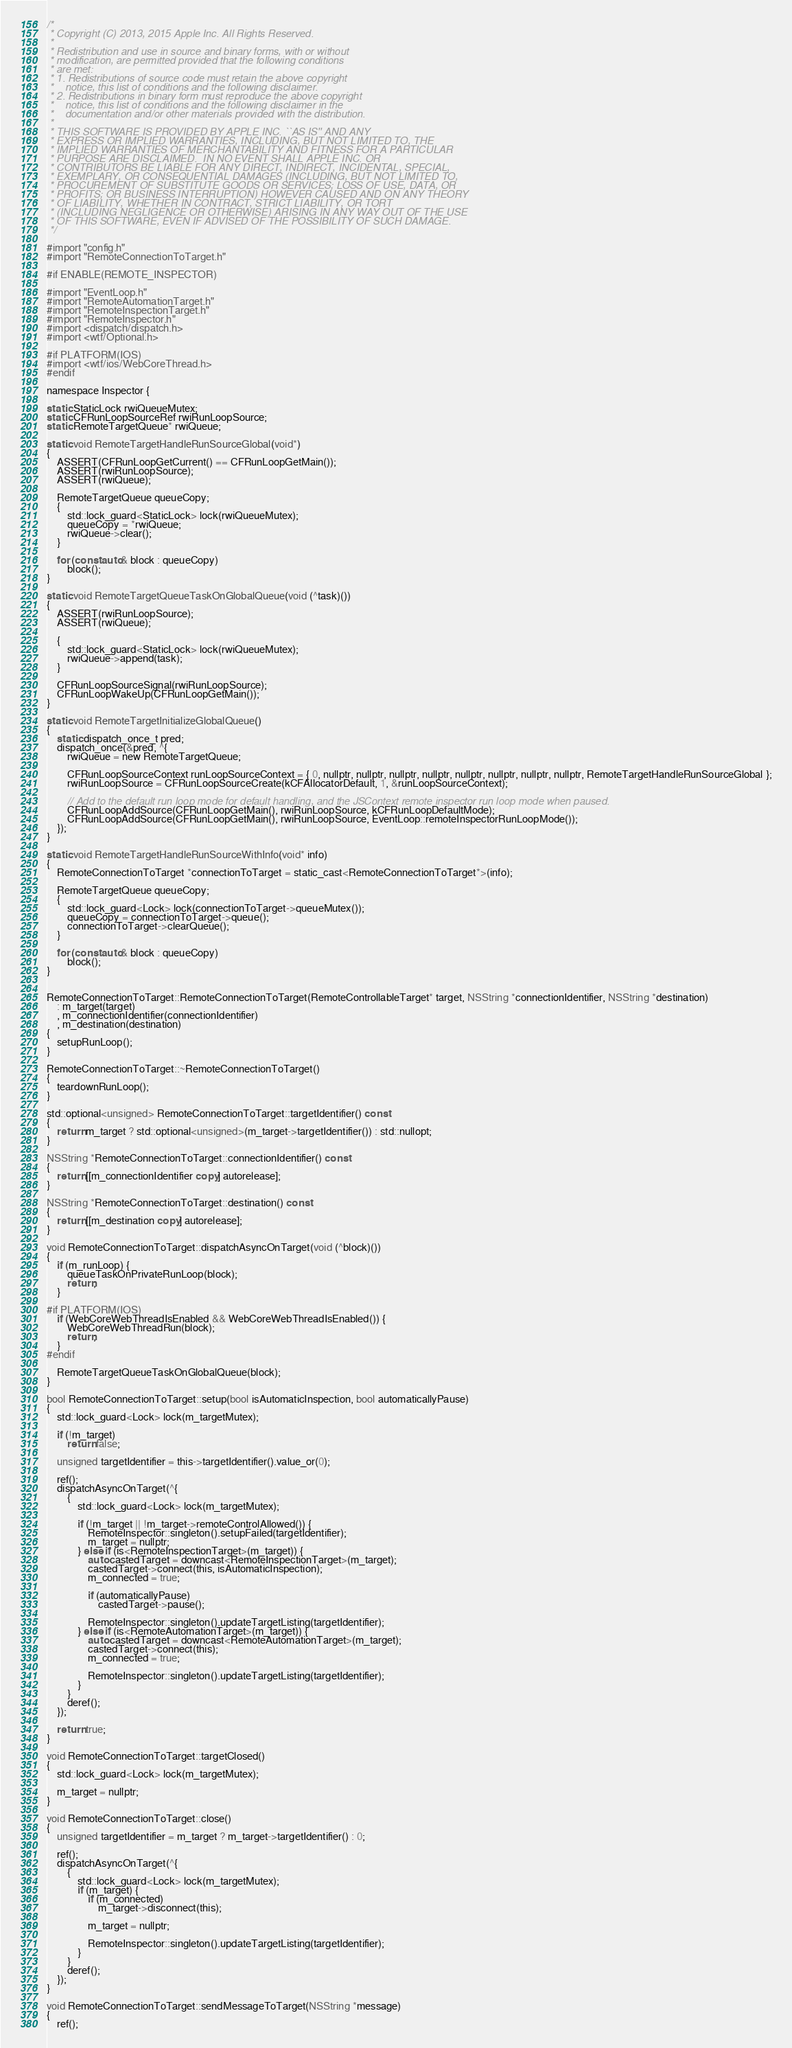<code> <loc_0><loc_0><loc_500><loc_500><_ObjectiveC_>/*
 * Copyright (C) 2013, 2015 Apple Inc. All Rights Reserved.
 *
 * Redistribution and use in source and binary forms, with or without
 * modification, are permitted provided that the following conditions
 * are met:
 * 1. Redistributions of source code must retain the above copyright
 *    notice, this list of conditions and the following disclaimer.
 * 2. Redistributions in binary form must reproduce the above copyright
 *    notice, this list of conditions and the following disclaimer in the
 *    documentation and/or other materials provided with the distribution.
 *
 * THIS SOFTWARE IS PROVIDED BY APPLE INC. ``AS IS'' AND ANY
 * EXPRESS OR IMPLIED WARRANTIES, INCLUDING, BUT NOT LIMITED TO, THE
 * IMPLIED WARRANTIES OF MERCHANTABILITY AND FITNESS FOR A PARTICULAR
 * PURPOSE ARE DISCLAIMED.  IN NO EVENT SHALL APPLE INC. OR
 * CONTRIBUTORS BE LIABLE FOR ANY DIRECT, INDIRECT, INCIDENTAL, SPECIAL,
 * EXEMPLARY, OR CONSEQUENTIAL DAMAGES (INCLUDING, BUT NOT LIMITED TO,
 * PROCUREMENT OF SUBSTITUTE GOODS OR SERVICES; LOSS OF USE, DATA, OR
 * PROFITS; OR BUSINESS INTERRUPTION) HOWEVER CAUSED AND ON ANY THEORY
 * OF LIABILITY, WHETHER IN CONTRACT, STRICT LIABILITY, OR TORT
 * (INCLUDING NEGLIGENCE OR OTHERWISE) ARISING IN ANY WAY OUT OF THE USE
 * OF THIS SOFTWARE, EVEN IF ADVISED OF THE POSSIBILITY OF SUCH DAMAGE.
 */

#import "config.h"
#import "RemoteConnectionToTarget.h"

#if ENABLE(REMOTE_INSPECTOR)

#import "EventLoop.h"
#import "RemoteAutomationTarget.h"
#import "RemoteInspectionTarget.h"
#import "RemoteInspector.h"
#import <dispatch/dispatch.h>
#import <wtf/Optional.h>

#if PLATFORM(IOS)
#import <wtf/ios/WebCoreThread.h>
#endif

namespace Inspector {

static StaticLock rwiQueueMutex;
static CFRunLoopSourceRef rwiRunLoopSource;
static RemoteTargetQueue* rwiQueue;

static void RemoteTargetHandleRunSourceGlobal(void*)
{
    ASSERT(CFRunLoopGetCurrent() == CFRunLoopGetMain());
    ASSERT(rwiRunLoopSource);
    ASSERT(rwiQueue);

    RemoteTargetQueue queueCopy;
    {
        std::lock_guard<StaticLock> lock(rwiQueueMutex);
        queueCopy = *rwiQueue;
        rwiQueue->clear();
    }

    for (const auto& block : queueCopy)
        block();
}

static void RemoteTargetQueueTaskOnGlobalQueue(void (^task)())
{
    ASSERT(rwiRunLoopSource);
    ASSERT(rwiQueue);

    {
        std::lock_guard<StaticLock> lock(rwiQueueMutex);
        rwiQueue->append(task);
    }

    CFRunLoopSourceSignal(rwiRunLoopSource);
    CFRunLoopWakeUp(CFRunLoopGetMain());
}

static void RemoteTargetInitializeGlobalQueue()
{
    static dispatch_once_t pred;
    dispatch_once(&pred, ^{
        rwiQueue = new RemoteTargetQueue;

        CFRunLoopSourceContext runLoopSourceContext = { 0, nullptr, nullptr, nullptr, nullptr, nullptr, nullptr, nullptr, nullptr, RemoteTargetHandleRunSourceGlobal };
        rwiRunLoopSource = CFRunLoopSourceCreate(kCFAllocatorDefault, 1, &runLoopSourceContext);

        // Add to the default run loop mode for default handling, and the JSContext remote inspector run loop mode when paused.
        CFRunLoopAddSource(CFRunLoopGetMain(), rwiRunLoopSource, kCFRunLoopDefaultMode);
        CFRunLoopAddSource(CFRunLoopGetMain(), rwiRunLoopSource, EventLoop::remoteInspectorRunLoopMode());
    });
}

static void RemoteTargetHandleRunSourceWithInfo(void* info)
{
    RemoteConnectionToTarget *connectionToTarget = static_cast<RemoteConnectionToTarget*>(info);

    RemoteTargetQueue queueCopy;
    {
        std::lock_guard<Lock> lock(connectionToTarget->queueMutex());
        queueCopy = connectionToTarget->queue();
        connectionToTarget->clearQueue();
    }

    for (const auto& block : queueCopy)
        block();
}


RemoteConnectionToTarget::RemoteConnectionToTarget(RemoteControllableTarget* target, NSString *connectionIdentifier, NSString *destination)
    : m_target(target)
    , m_connectionIdentifier(connectionIdentifier)
    , m_destination(destination)
{
    setupRunLoop();
}

RemoteConnectionToTarget::~RemoteConnectionToTarget()
{
    teardownRunLoop();
}

std::optional<unsigned> RemoteConnectionToTarget::targetIdentifier() const
{
    return m_target ? std::optional<unsigned>(m_target->targetIdentifier()) : std::nullopt;
}

NSString *RemoteConnectionToTarget::connectionIdentifier() const
{
    return [[m_connectionIdentifier copy] autorelease];
}

NSString *RemoteConnectionToTarget::destination() const
{
    return [[m_destination copy] autorelease];
}

void RemoteConnectionToTarget::dispatchAsyncOnTarget(void (^block)())
{
    if (m_runLoop) {
        queueTaskOnPrivateRunLoop(block);
        return;
    }

#if PLATFORM(IOS)
    if (WebCoreWebThreadIsEnabled && WebCoreWebThreadIsEnabled()) {
        WebCoreWebThreadRun(block);
        return;
    }
#endif

    RemoteTargetQueueTaskOnGlobalQueue(block);
}

bool RemoteConnectionToTarget::setup(bool isAutomaticInspection, bool automaticallyPause)
{
    std::lock_guard<Lock> lock(m_targetMutex);

    if (!m_target)
        return false;

    unsigned targetIdentifier = this->targetIdentifier().value_or(0);
    
    ref();
    dispatchAsyncOnTarget(^{
        {
            std::lock_guard<Lock> lock(m_targetMutex);

            if (!m_target || !m_target->remoteControlAllowed()) {
                RemoteInspector::singleton().setupFailed(targetIdentifier);
                m_target = nullptr;
            } else if (is<RemoteInspectionTarget>(m_target)) {
                auto castedTarget = downcast<RemoteInspectionTarget>(m_target);
                castedTarget->connect(this, isAutomaticInspection);
                m_connected = true;

                if (automaticallyPause)
                    castedTarget->pause();

                RemoteInspector::singleton().updateTargetListing(targetIdentifier);
            } else if (is<RemoteAutomationTarget>(m_target)) {
                auto castedTarget = downcast<RemoteAutomationTarget>(m_target);
                castedTarget->connect(this);
                m_connected = true;

                RemoteInspector::singleton().updateTargetListing(targetIdentifier);
            }
        }
        deref();
    });

    return true;
}

void RemoteConnectionToTarget::targetClosed()
{
    std::lock_guard<Lock> lock(m_targetMutex);

    m_target = nullptr;
}

void RemoteConnectionToTarget::close()
{
    unsigned targetIdentifier = m_target ? m_target->targetIdentifier() : 0;
    
    ref();
    dispatchAsyncOnTarget(^{
        {
            std::lock_guard<Lock> lock(m_targetMutex);
            if (m_target) {
                if (m_connected)
                    m_target->disconnect(this);

                m_target = nullptr;
                
                RemoteInspector::singleton().updateTargetListing(targetIdentifier);
            }
        }
        deref();
    });
}

void RemoteConnectionToTarget::sendMessageToTarget(NSString *message)
{
    ref();</code> 